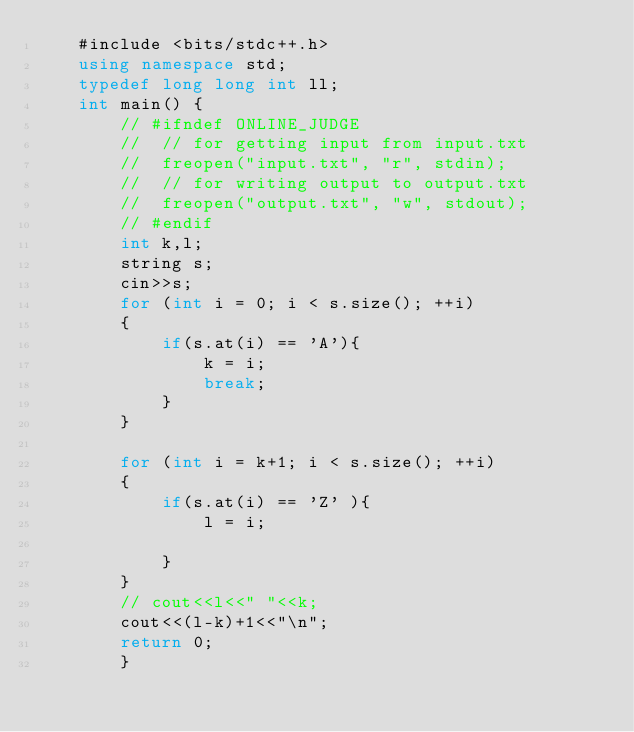Convert code to text. <code><loc_0><loc_0><loc_500><loc_500><_C++_>	#include <bits/stdc++.h>
	using namespace std;
	typedef long long int ll;
	int main() {
		// #ifndef ONLINE_JUDGE
		// 	// for getting input from input.txt
		// 	freopen("input.txt", "r", stdin);
		// 	// for writing output to output.txt
		// 	freopen("output.txt", "w", stdout);
		// #endif
		int k,l;
	 	string s;
	 	cin>>s;
	 	for (int i = 0; i < s.size(); ++i)
	 	{
	 		if(s.at(i) == 'A'){
	 			k = i;
	 			break;
	 		}
	 	}

	 	for (int i = k+1; i < s.size(); ++i)
	 	{
	 		if(s.at(i) == 'Z' ){
	 			l = i;
	 		
	 		}
	 	}
	 	// cout<<l<<" "<<k;
	 	cout<<(l-k)+1<<"\n";
		return 0;
		}	</code> 